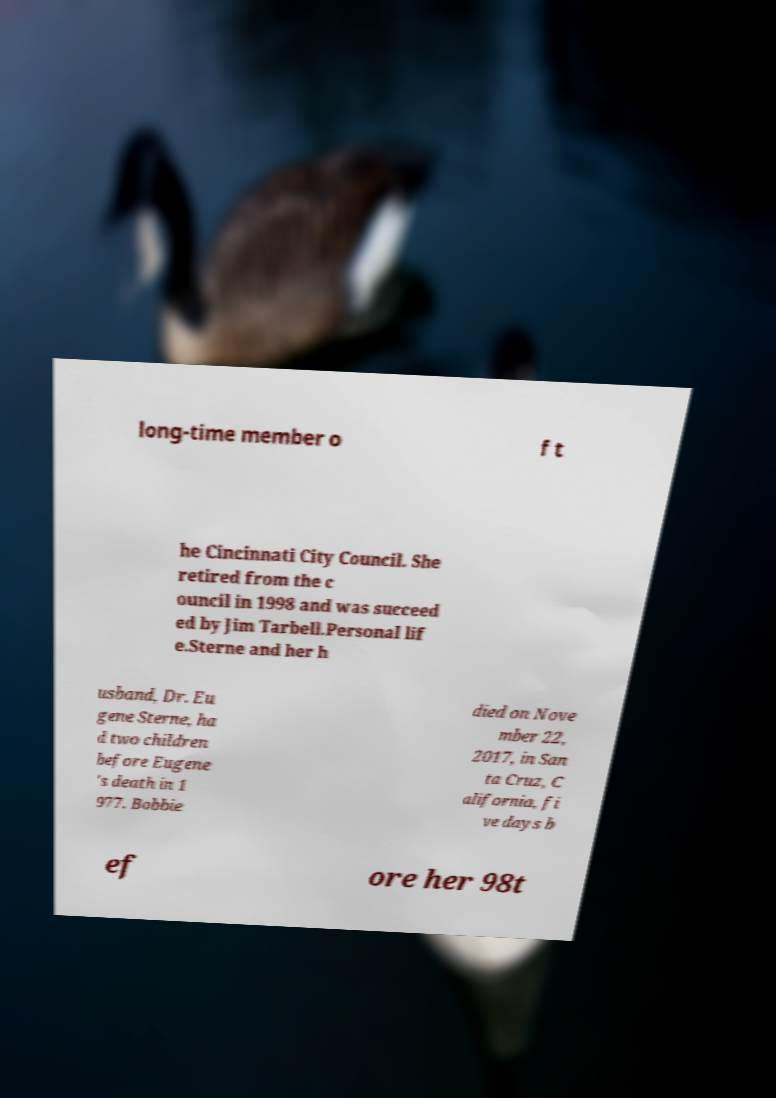For documentation purposes, I need the text within this image transcribed. Could you provide that? long-time member o f t he Cincinnati City Council. She retired from the c ouncil in 1998 and was succeed ed by Jim Tarbell.Personal lif e.Sterne and her h usband, Dr. Eu gene Sterne, ha d two children before Eugene 's death in 1 977. Bobbie died on Nove mber 22, 2017, in San ta Cruz, C alifornia, fi ve days b ef ore her 98t 